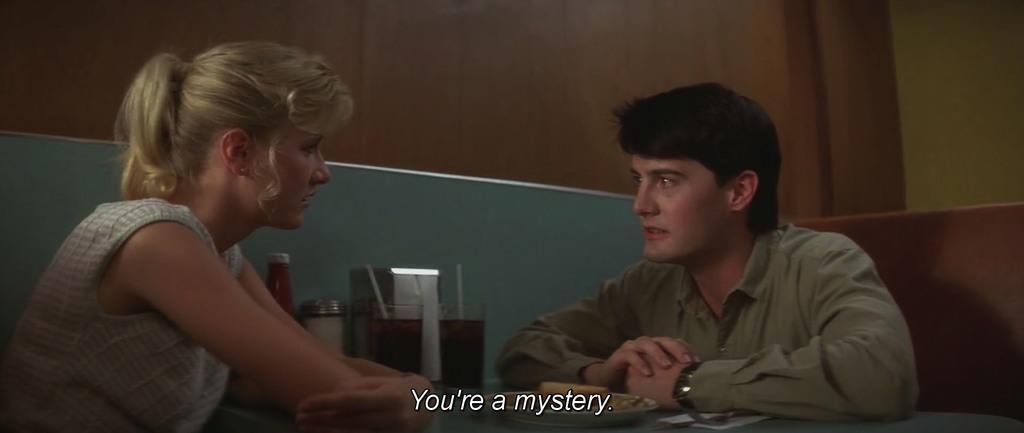In one or two sentences, can you explain what this image depicts? this image there are two persons sitting and talking to each other at the middle of the image there are some drinks and bottles and at the background of the image there is a wall. 